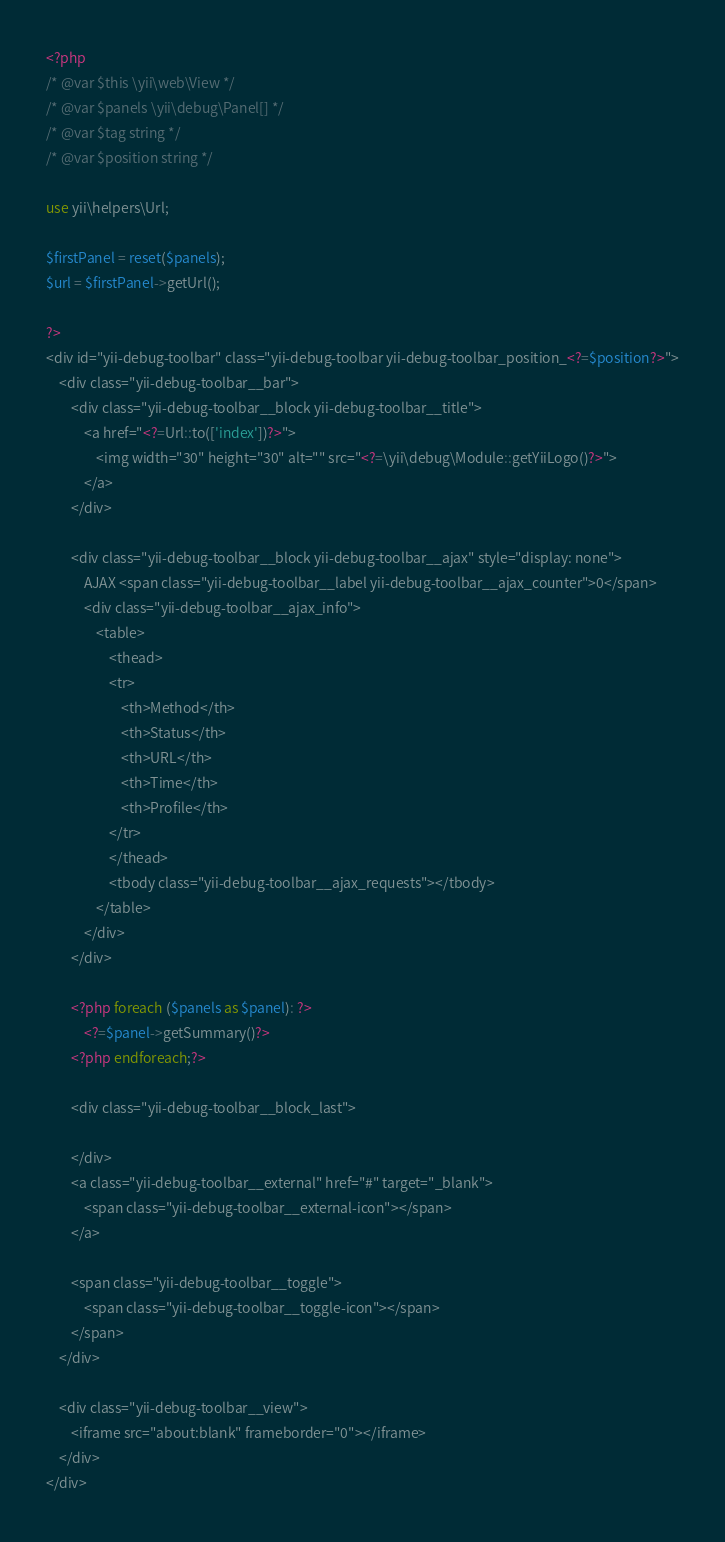<code> <loc_0><loc_0><loc_500><loc_500><_PHP_><?php
/* @var $this \yii\web\View */
/* @var $panels \yii\debug\Panel[] */
/* @var $tag string */
/* @var $position string */

use yii\helpers\Url;

$firstPanel = reset($panels);
$url = $firstPanel->getUrl();

?>
<div id="yii-debug-toolbar" class="yii-debug-toolbar yii-debug-toolbar_position_<?=$position?>">
    <div class="yii-debug-toolbar__bar">
        <div class="yii-debug-toolbar__block yii-debug-toolbar__title">
            <a href="<?=Url::to(['index'])?>">
                <img width="30" height="30" alt="" src="<?=\yii\debug\Module::getYiiLogo()?>">
            </a>
        </div>

        <div class="yii-debug-toolbar__block yii-debug-toolbar__ajax" style="display: none">
            AJAX <span class="yii-debug-toolbar__label yii-debug-toolbar__ajax_counter">0</span>
            <div class="yii-debug-toolbar__ajax_info">
                <table>
                    <thead>
                    <tr>
                        <th>Method</th>
                        <th>Status</th>
                        <th>URL</th>
                        <th>Time</th>
                        <th>Profile</th>
                    </tr>
                    </thead>
                    <tbody class="yii-debug-toolbar__ajax_requests"></tbody>
                </table>
            </div>
        </div>

        <?php foreach ($panels as $panel): ?>
            <?=$panel->getSummary()?>
        <?php endforeach;?>

        <div class="yii-debug-toolbar__block_last">

        </div>
        <a class="yii-debug-toolbar__external" href="#" target="_blank">
            <span class="yii-debug-toolbar__external-icon"></span>
        </a>

        <span class="yii-debug-toolbar__toggle">
            <span class="yii-debug-toolbar__toggle-icon"></span>
        </span>
    </div>

    <div class="yii-debug-toolbar__view">
        <iframe src="about:blank" frameborder="0"></iframe>
    </div>
</div>
</code> 